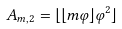<formula> <loc_0><loc_0><loc_500><loc_500>A _ { m , 2 } = \lfloor \lfloor m \varphi \rfloor \varphi ^ { 2 } \rfloor</formula> 